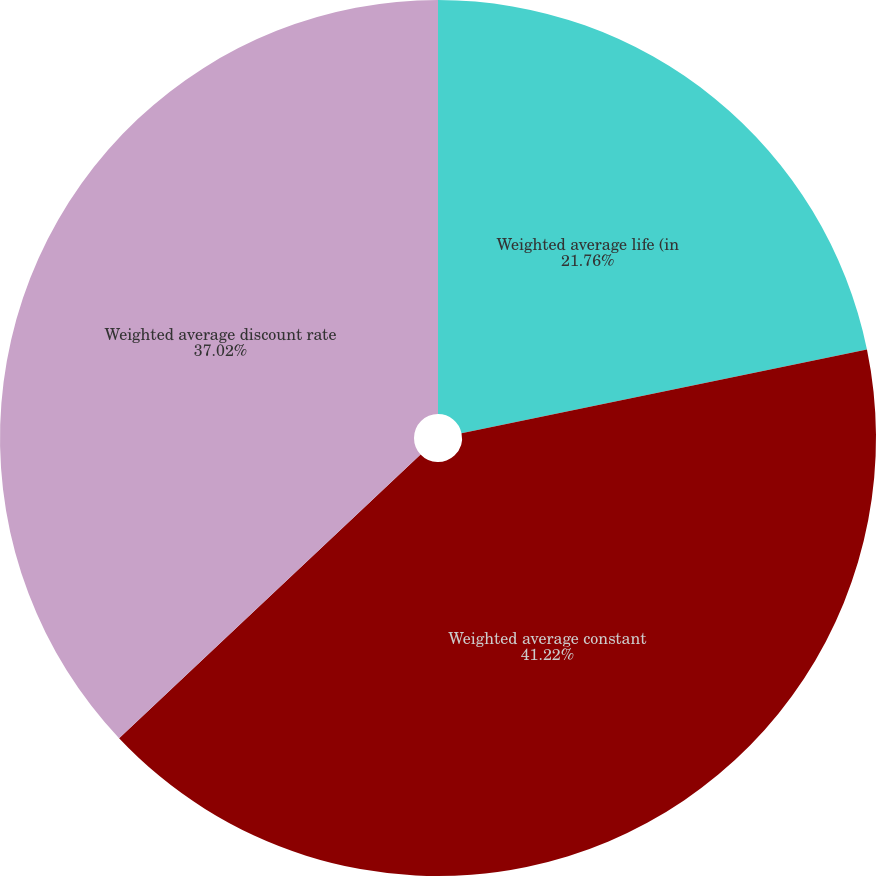Convert chart. <chart><loc_0><loc_0><loc_500><loc_500><pie_chart><fcel>Weighted average life (in<fcel>Weighted average constant<fcel>Weighted average discount rate<nl><fcel>21.76%<fcel>41.22%<fcel>37.02%<nl></chart> 